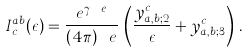Convert formula to latex. <formula><loc_0><loc_0><loc_500><loc_500>I ^ { a b } _ { c } ( \epsilon ) = \frac { e ^ { \gamma \ e } } { ( 4 \pi ) ^ { \ } e } \, \left ( \frac { y ^ { c } _ { a , b ; 2 } } { \epsilon } + y ^ { c } _ { a , b ; 3 } \right ) \, .</formula> 